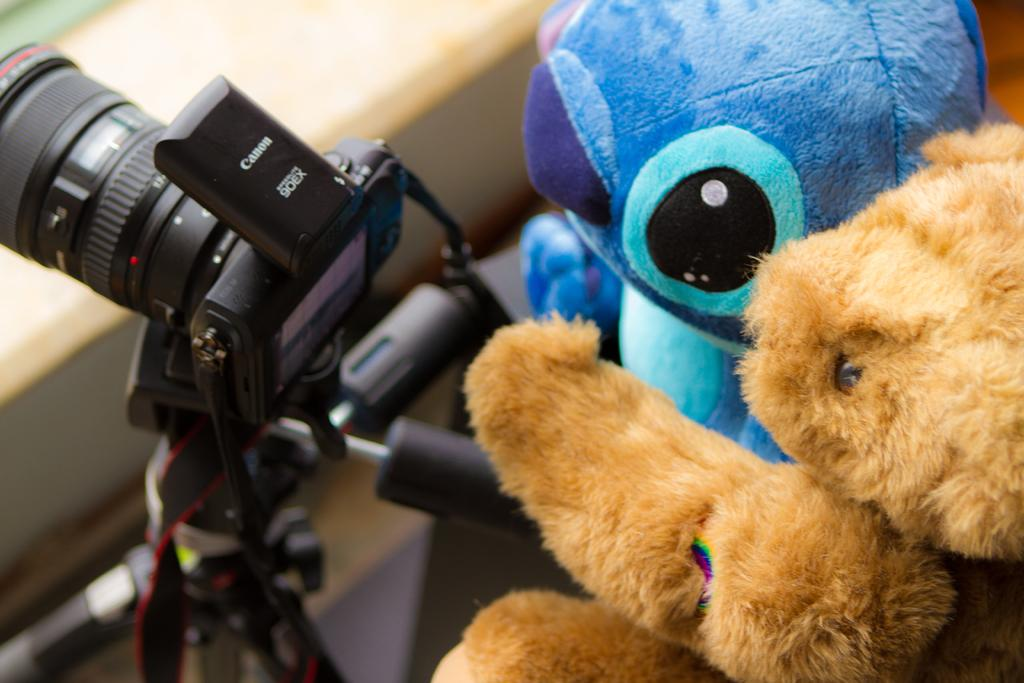What objects are in the front of the image? There are dolls in the front of the image. What can be seen on the left side of the image? There is a camera on the left side of the image. What is the color of the camera? The camera is black in color. Is there any text on the camera? Yes, there is text written on the camera. What type of stamp is visible on the doll's dress in the image? There is no stamp or dress present on the dolls in the image. What color is the ink used for writing on the camera? There is no ink visible in the image, as the text on the camera is likely printed or engraved. 